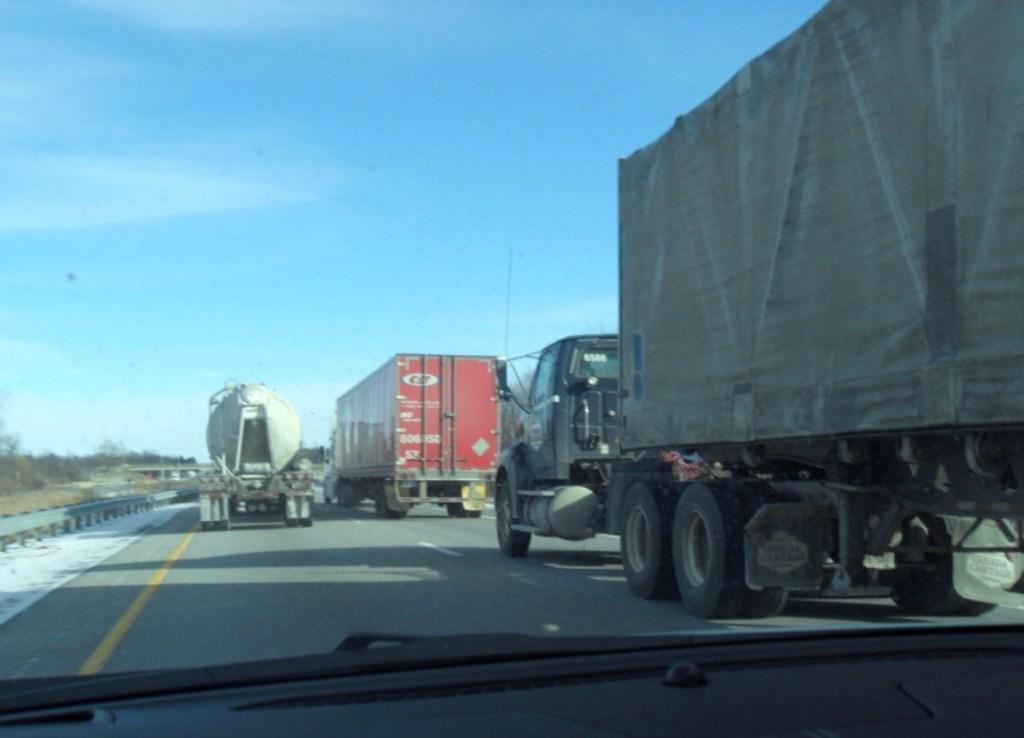What type of vehicles can be seen on the road in the image? There are trucks on the road in the image. What safety feature is present next to the road? There is a railing next to the road. What can be seen in the background of the image? Plants and the sky are visible in the background. What type of cent is visible in the image? A: There is no cent present in the image. What type of umbrella is being used by the plants in the image? There is no umbrella present in the image, and plants do not use umbrellas. 